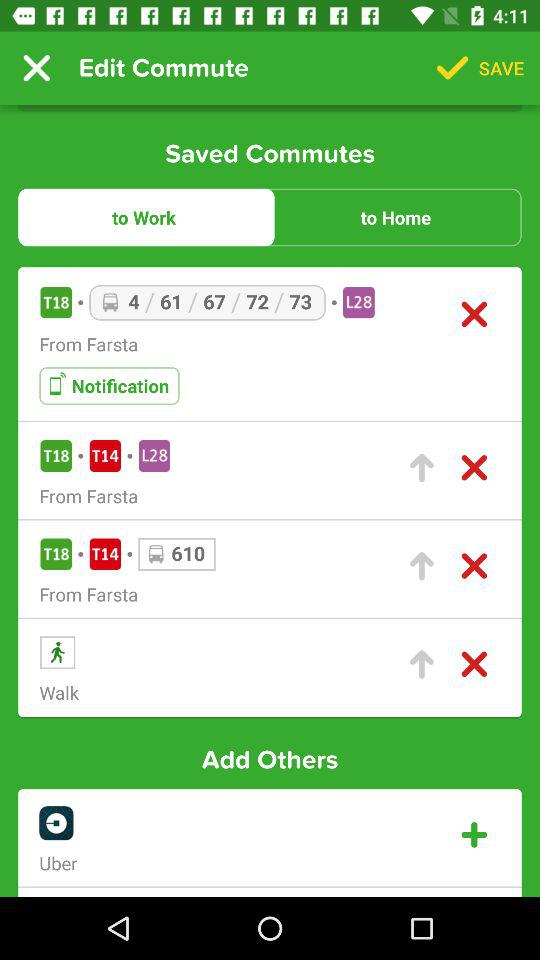Which tab is selected? The selected tab is "to Work". 